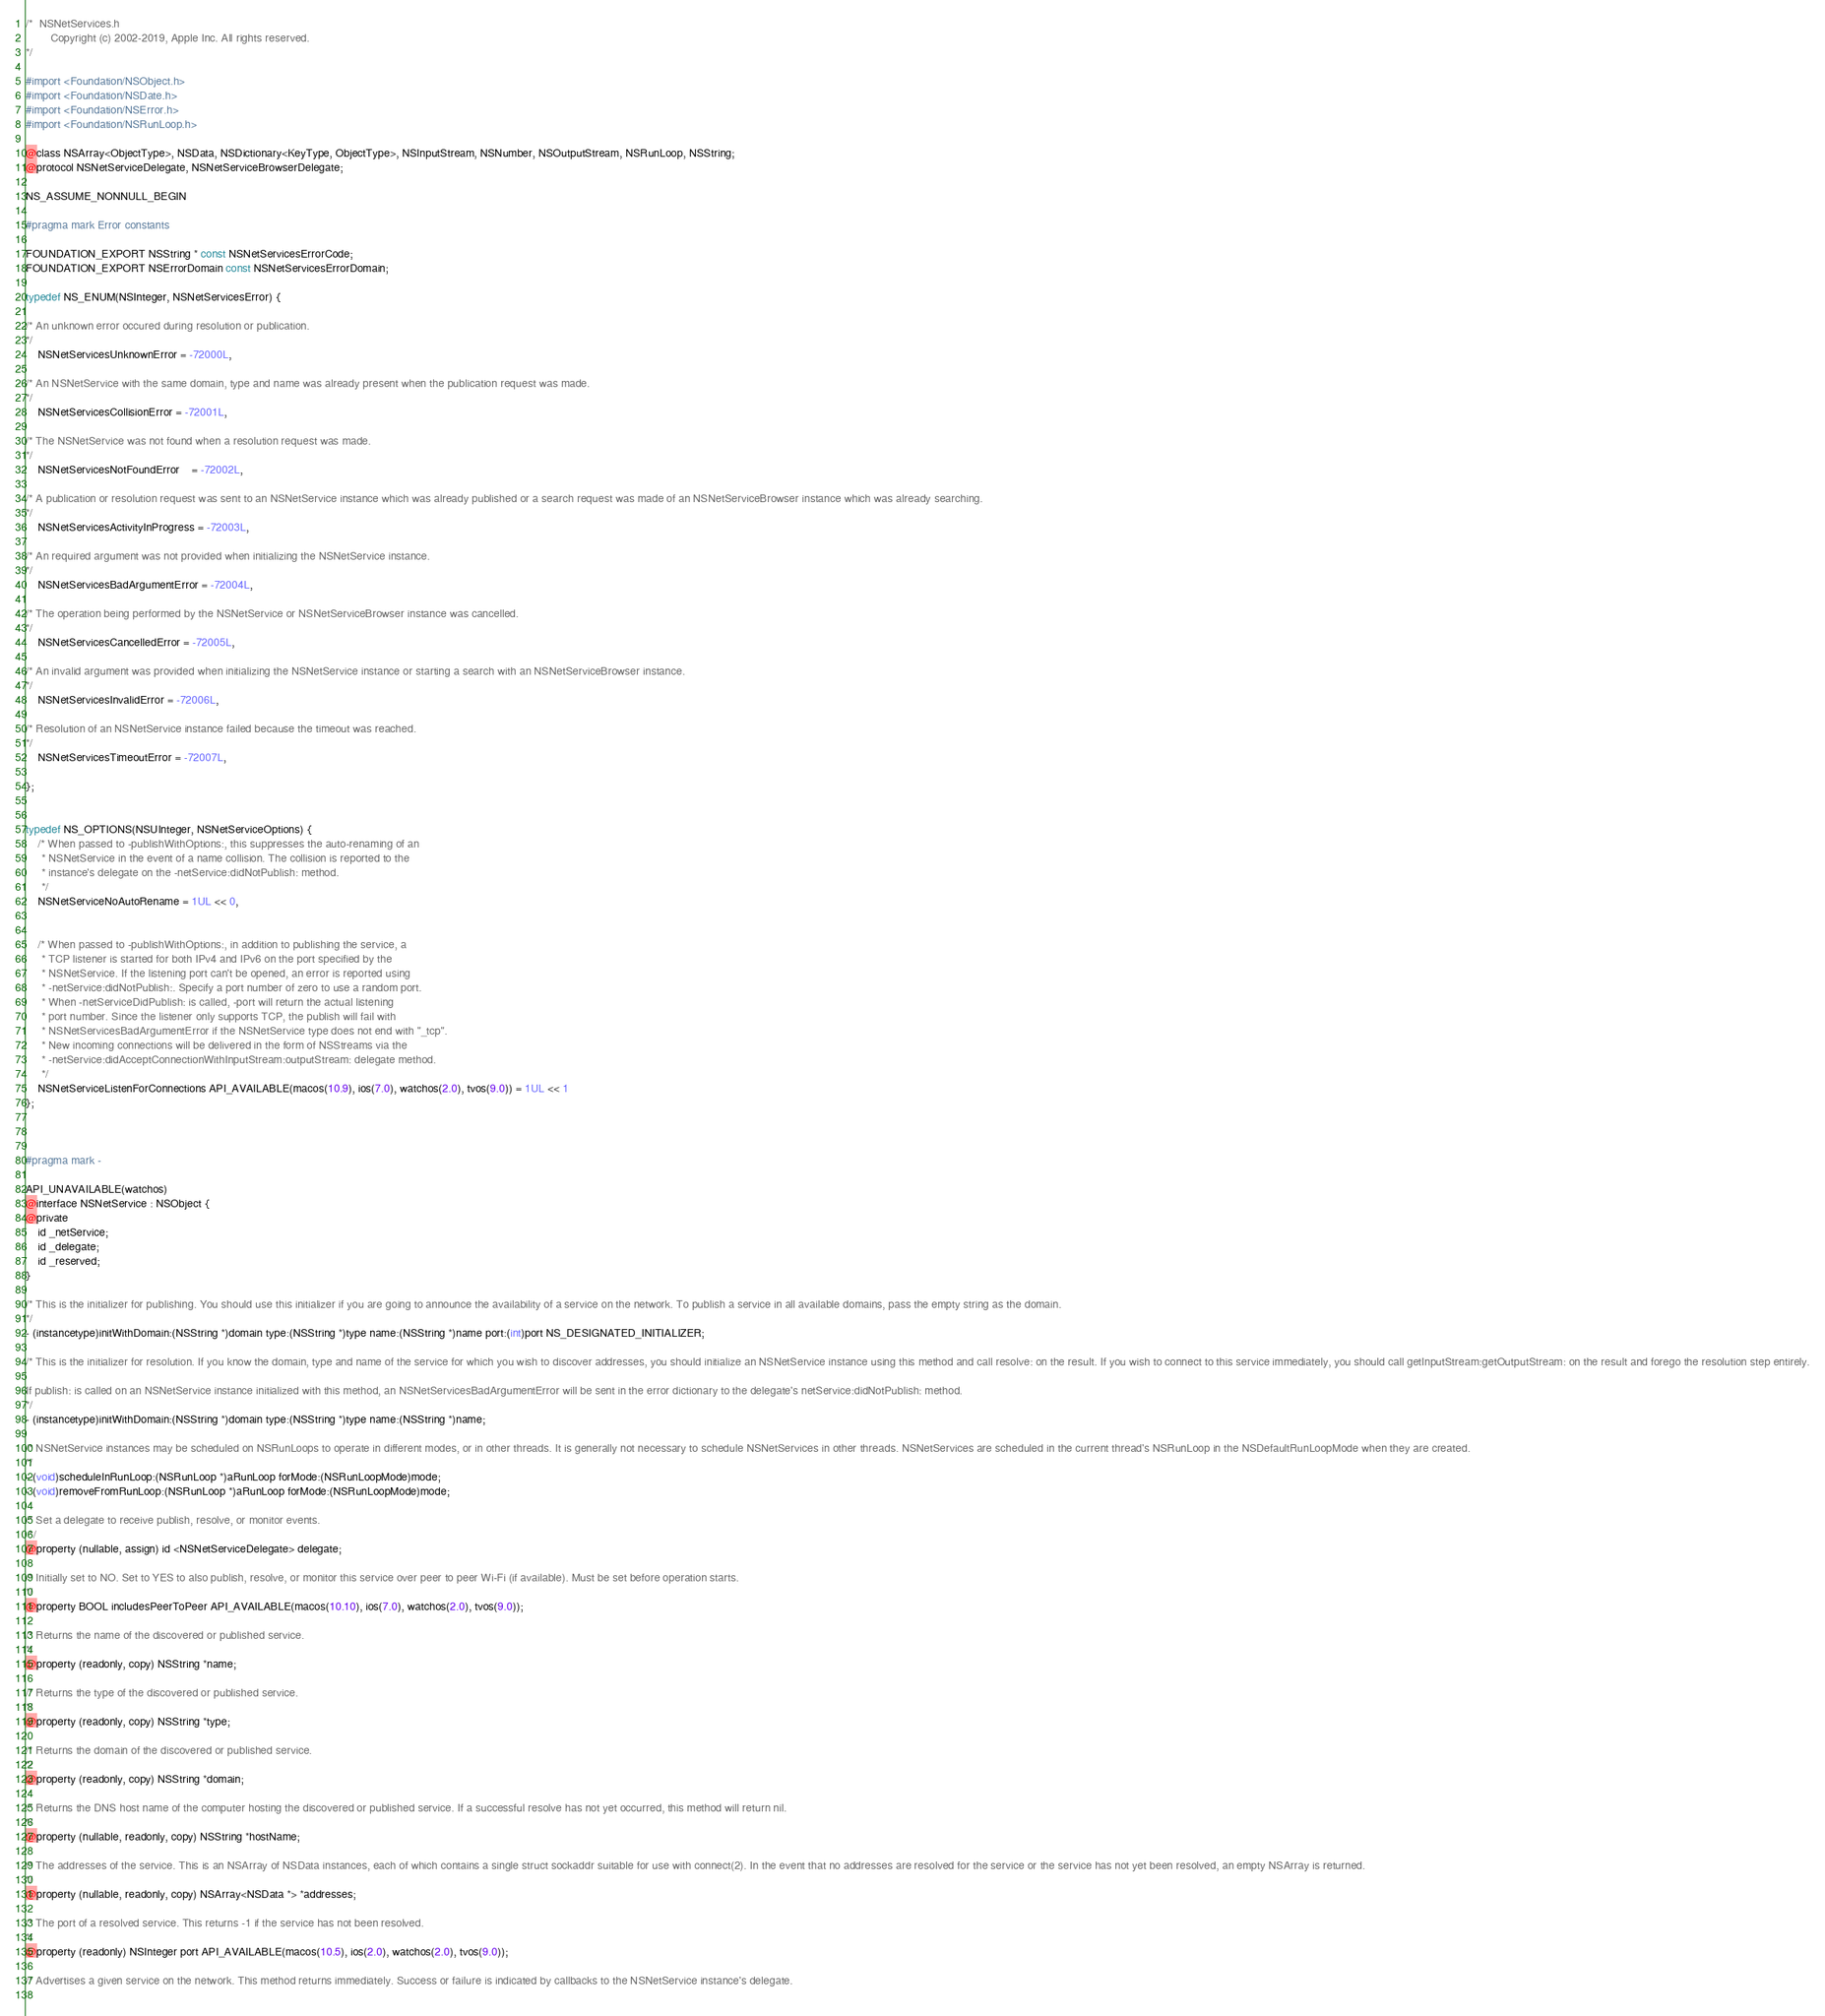Convert code to text. <code><loc_0><loc_0><loc_500><loc_500><_C_>/*	NSNetServices.h
        Copyright (c) 2002-2019, Apple Inc. All rights reserved.
*/

#import <Foundation/NSObject.h>
#import <Foundation/NSDate.h>
#import <Foundation/NSError.h>
#import <Foundation/NSRunLoop.h>

@class NSArray<ObjectType>, NSData, NSDictionary<KeyType, ObjectType>, NSInputStream, NSNumber, NSOutputStream, NSRunLoop, NSString;
@protocol NSNetServiceDelegate, NSNetServiceBrowserDelegate;

NS_ASSUME_NONNULL_BEGIN

#pragma mark Error constants

FOUNDATION_EXPORT NSString * const NSNetServicesErrorCode;
FOUNDATION_EXPORT NSErrorDomain const NSNetServicesErrorDomain;

typedef NS_ENUM(NSInteger, NSNetServicesError) {
    
/* An unknown error occured during resolution or publication.
*/
    NSNetServicesUnknownError = -72000L,
    
/* An NSNetService with the same domain, type and name was already present when the publication request was made.
*/
    NSNetServicesCollisionError = -72001L,
    
/* The NSNetService was not found when a resolution request was made.
*/
    NSNetServicesNotFoundError	= -72002L,
    
/* A publication or resolution request was sent to an NSNetService instance which was already published or a search request was made of an NSNetServiceBrowser instance which was already searching.
*/
    NSNetServicesActivityInProgress = -72003L,
    
/* An required argument was not provided when initializing the NSNetService instance.
*/
    NSNetServicesBadArgumentError = -72004L,
    
/* The operation being performed by the NSNetService or NSNetServiceBrowser instance was cancelled.
*/
    NSNetServicesCancelledError = -72005L,
    
/* An invalid argument was provided when initializing the NSNetService instance or starting a search with an NSNetServiceBrowser instance.
*/
    NSNetServicesInvalidError = -72006L,
        
/* Resolution of an NSNetService instance failed because the timeout was reached.
*/
    NSNetServicesTimeoutError = -72007L,
    
};


typedef NS_OPTIONS(NSUInteger, NSNetServiceOptions) {
    /* When passed to -publishWithOptions:, this suppresses the auto-renaming of an
     * NSNetService in the event of a name collision. The collision is reported to the
     * instance's delegate on the -netService:didNotPublish: method.
     */
    NSNetServiceNoAutoRename = 1UL << 0,


    /* When passed to -publishWithOptions:, in addition to publishing the service, a
     * TCP listener is started for both IPv4 and IPv6 on the port specified by the
     * NSNetService. If the listening port can't be opened, an error is reported using
     * -netService:didNotPublish:. Specify a port number of zero to use a random port.
     * When -netServiceDidPublish: is called, -port will return the actual listening
     * port number. Since the listener only supports TCP, the publish will fail with
     * NSNetServicesBadArgumentError if the NSNetService type does not end with "_tcp".
     * New incoming connections will be delivered in the form of NSStreams via the
     * -netService:didAcceptConnectionWithInputStream:outputStream: delegate method.
     */
    NSNetServiceListenForConnections API_AVAILABLE(macos(10.9), ios(7.0), watchos(2.0), tvos(9.0)) = 1UL << 1
};



#pragma mark -

API_UNAVAILABLE(watchos)
@interface NSNetService : NSObject {
@private
    id _netService;
    id _delegate;
    id _reserved;
}

/* This is the initializer for publishing. You should use this initializer if you are going to announce the availability of a service on the network. To publish a service in all available domains, pass the empty string as the domain.
*/
- (instancetype)initWithDomain:(NSString *)domain type:(NSString *)type name:(NSString *)name port:(int)port NS_DESIGNATED_INITIALIZER;

/* This is the initializer for resolution. If you know the domain, type and name of the service for which you wish to discover addresses, you should initialize an NSNetService instance using this method and call resolve: on the result. If you wish to connect to this service immediately, you should call getInputStream:getOutputStream: on the result and forego the resolution step entirely.

If publish: is called on an NSNetService instance initialized with this method, an NSNetServicesBadArgumentError will be sent in the error dictionary to the delegate's netService:didNotPublish: method.
*/
- (instancetype)initWithDomain:(NSString *)domain type:(NSString *)type name:(NSString *)name;

/* NSNetService instances may be scheduled on NSRunLoops to operate in different modes, or in other threads. It is generally not necessary to schedule NSNetServices in other threads. NSNetServices are scheduled in the current thread's NSRunLoop in the NSDefaultRunLoopMode when they are created.
*/
- (void)scheduleInRunLoop:(NSRunLoop *)aRunLoop forMode:(NSRunLoopMode)mode;
- (void)removeFromRunLoop:(NSRunLoop *)aRunLoop forMode:(NSRunLoopMode)mode;

/* Set a delegate to receive publish, resolve, or monitor events.
 */
@property (nullable, assign) id <NSNetServiceDelegate> delegate;

/* Initially set to NO. Set to YES to also publish, resolve, or monitor this service over peer to peer Wi-Fi (if available). Must be set before operation starts.
*/
@property BOOL includesPeerToPeer API_AVAILABLE(macos(10.10), ios(7.0), watchos(2.0), tvos(9.0));

/* Returns the name of the discovered or published service.
*/
@property (readonly, copy) NSString *name;

/* Returns the type of the discovered or published service.
*/
@property (readonly, copy) NSString *type;

/* Returns the domain of the discovered or published service.
*/
@property (readonly, copy) NSString *domain;

/* Returns the DNS host name of the computer hosting the discovered or published service. If a successful resolve has not yet occurred, this method will return nil.
*/
@property (nullable, readonly, copy) NSString *hostName;

/* The addresses of the service. This is an NSArray of NSData instances, each of which contains a single struct sockaddr suitable for use with connect(2). In the event that no addresses are resolved for the service or the service has not yet been resolved, an empty NSArray is returned.
*/
@property (nullable, readonly, copy) NSArray<NSData *> *addresses;

/* The port of a resolved service. This returns -1 if the service has not been resolved.
*/
@property (readonly) NSInteger port API_AVAILABLE(macos(10.5), ios(2.0), watchos(2.0), tvos(9.0));
 
/* Advertises a given service on the network. This method returns immediately. Success or failure is indicated by callbacks to the NSNetService instance's delegate.
 </code> 